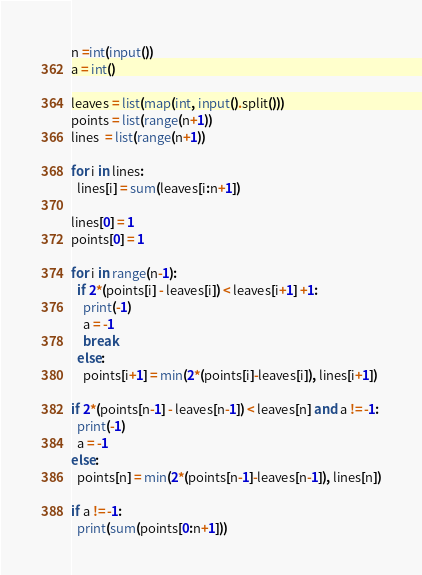Convert code to text. <code><loc_0><loc_0><loc_500><loc_500><_Python_>n =int(input())
a = int()

leaves = list(map(int, input().split()))
points = list(range(n+1))
lines  = list(range(n+1))

for i in lines:
  lines[i] = sum(leaves[i:n+1])

lines[0] = 1
points[0] = 1

for i in range(n-1):
  if 2*(points[i] - leaves[i]) < leaves[i+1] +1:
    print(-1)
    a = -1
    break
  else:
    points[i+1] = min(2*(points[i]-leaves[i]), lines[i+1])

if 2*(points[n-1] - leaves[n-1]) < leaves[n] and a != -1:
  print(-1)
  a = -1
else:
  points[n] = min(2*(points[n-1]-leaves[n-1]), lines[n])

if a != -1:
  print(sum(points[0:n+1]))
</code> 